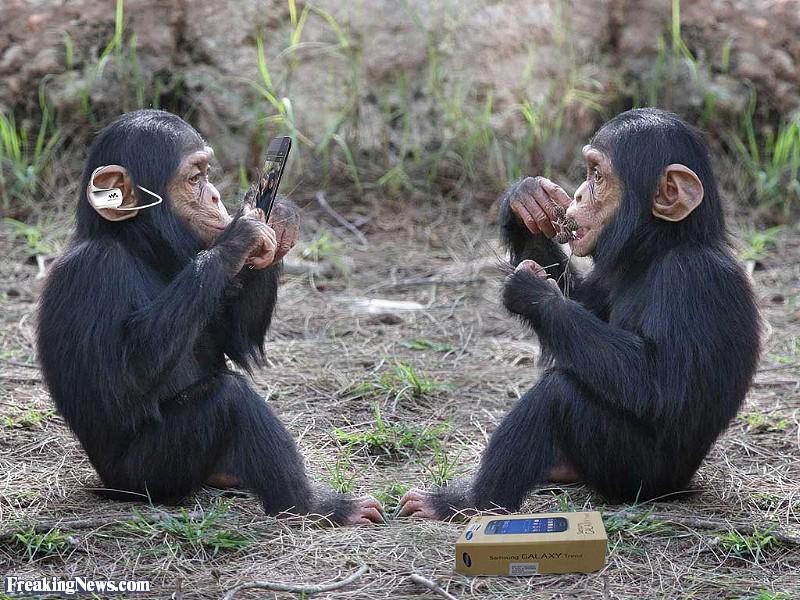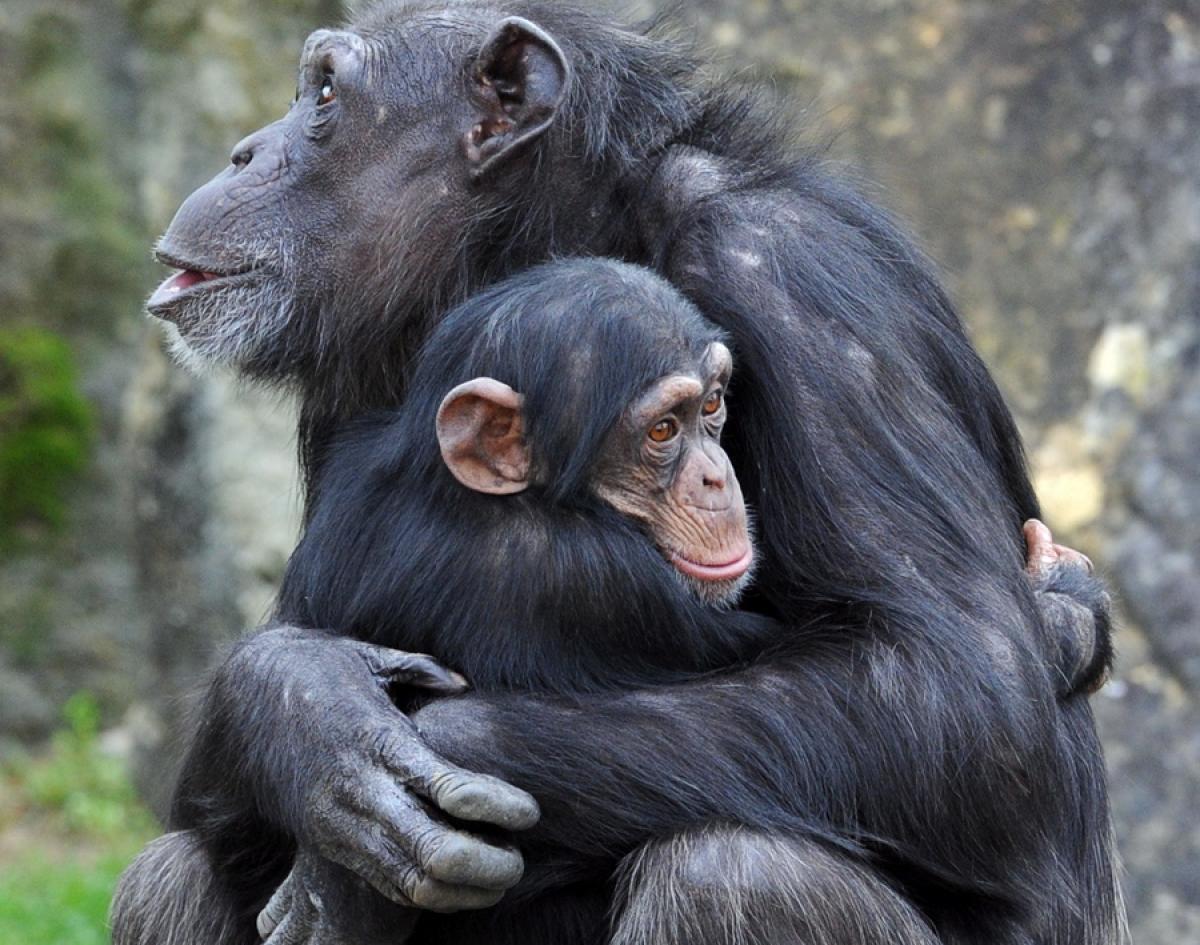The first image is the image on the left, the second image is the image on the right. Assess this claim about the two images: "There is a baby monkey being held by its mother.". Correct or not? Answer yes or no. Yes. The first image is the image on the left, the second image is the image on the right. Given the left and right images, does the statement "One chimp is holding another chimp." hold true? Answer yes or no. Yes. 